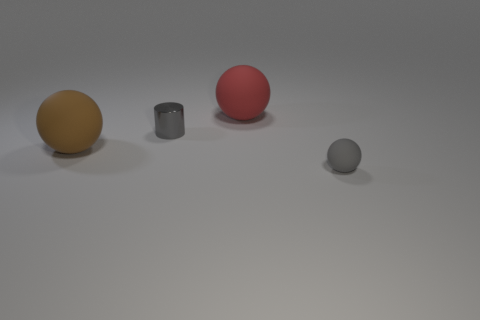Subtract all tiny balls. How many balls are left? 2 Subtract all brown balls. How many balls are left? 2 Subtract 2 balls. How many balls are left? 1 Add 1 rubber spheres. How many objects exist? 5 Subtract all balls. How many objects are left? 1 Add 1 tiny cyan rubber cylinders. How many tiny cyan rubber cylinders exist? 1 Subtract 0 yellow cylinders. How many objects are left? 4 Subtract all green spheres. Subtract all cyan cylinders. How many spheres are left? 3 Subtract all brown spheres. How many brown cylinders are left? 0 Subtract all tiny cyan matte blocks. Subtract all cylinders. How many objects are left? 3 